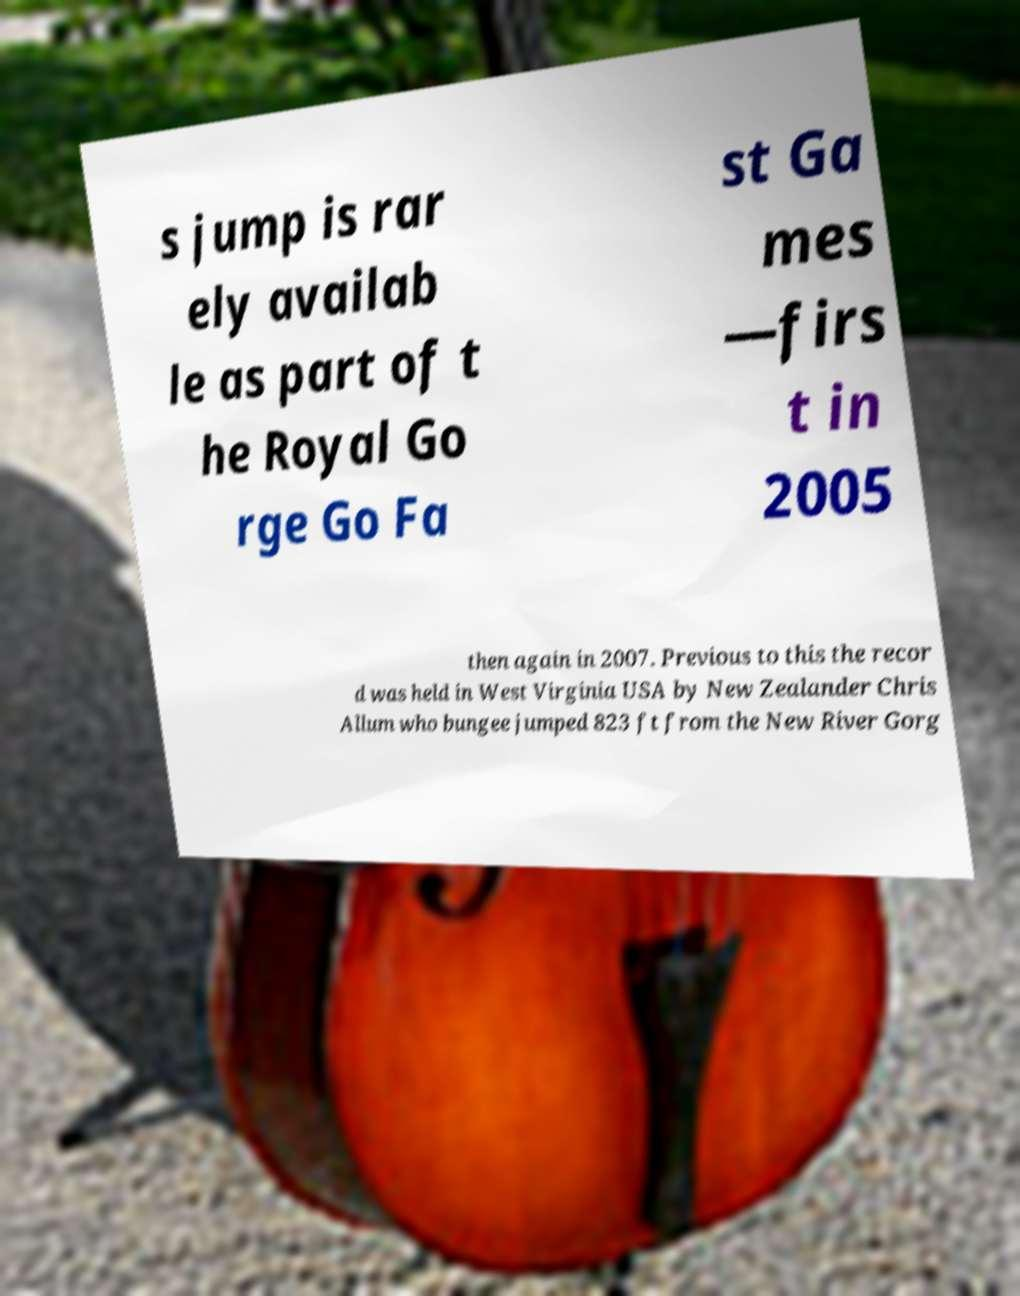For documentation purposes, I need the text within this image transcribed. Could you provide that? s jump is rar ely availab le as part of t he Royal Go rge Go Fa st Ga mes —firs t in 2005 then again in 2007. Previous to this the recor d was held in West Virginia USA by New Zealander Chris Allum who bungee jumped 823 ft from the New River Gorg 